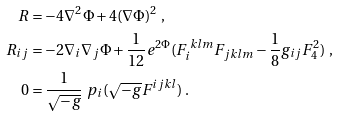Convert formula to latex. <formula><loc_0><loc_0><loc_500><loc_500>R & = - 4 \nabla ^ { 2 } \Phi + 4 ( \nabla \Phi ) ^ { 2 } \ , \\ R _ { i j } & = - 2 \nabla _ { i } \nabla _ { j } \Phi + \frac { 1 } { 1 2 } e ^ { 2 \Phi } ( F _ { i } ^ { \ k l m } F _ { j k l m } - \frac { 1 } { 8 } g _ { i j } F _ { 4 } ^ { 2 } ) \ , \\ 0 & = \frac { 1 } { \sqrt { - g } } \ p _ { i } ( \sqrt { - g } F ^ { i j k l } ) \ .</formula> 